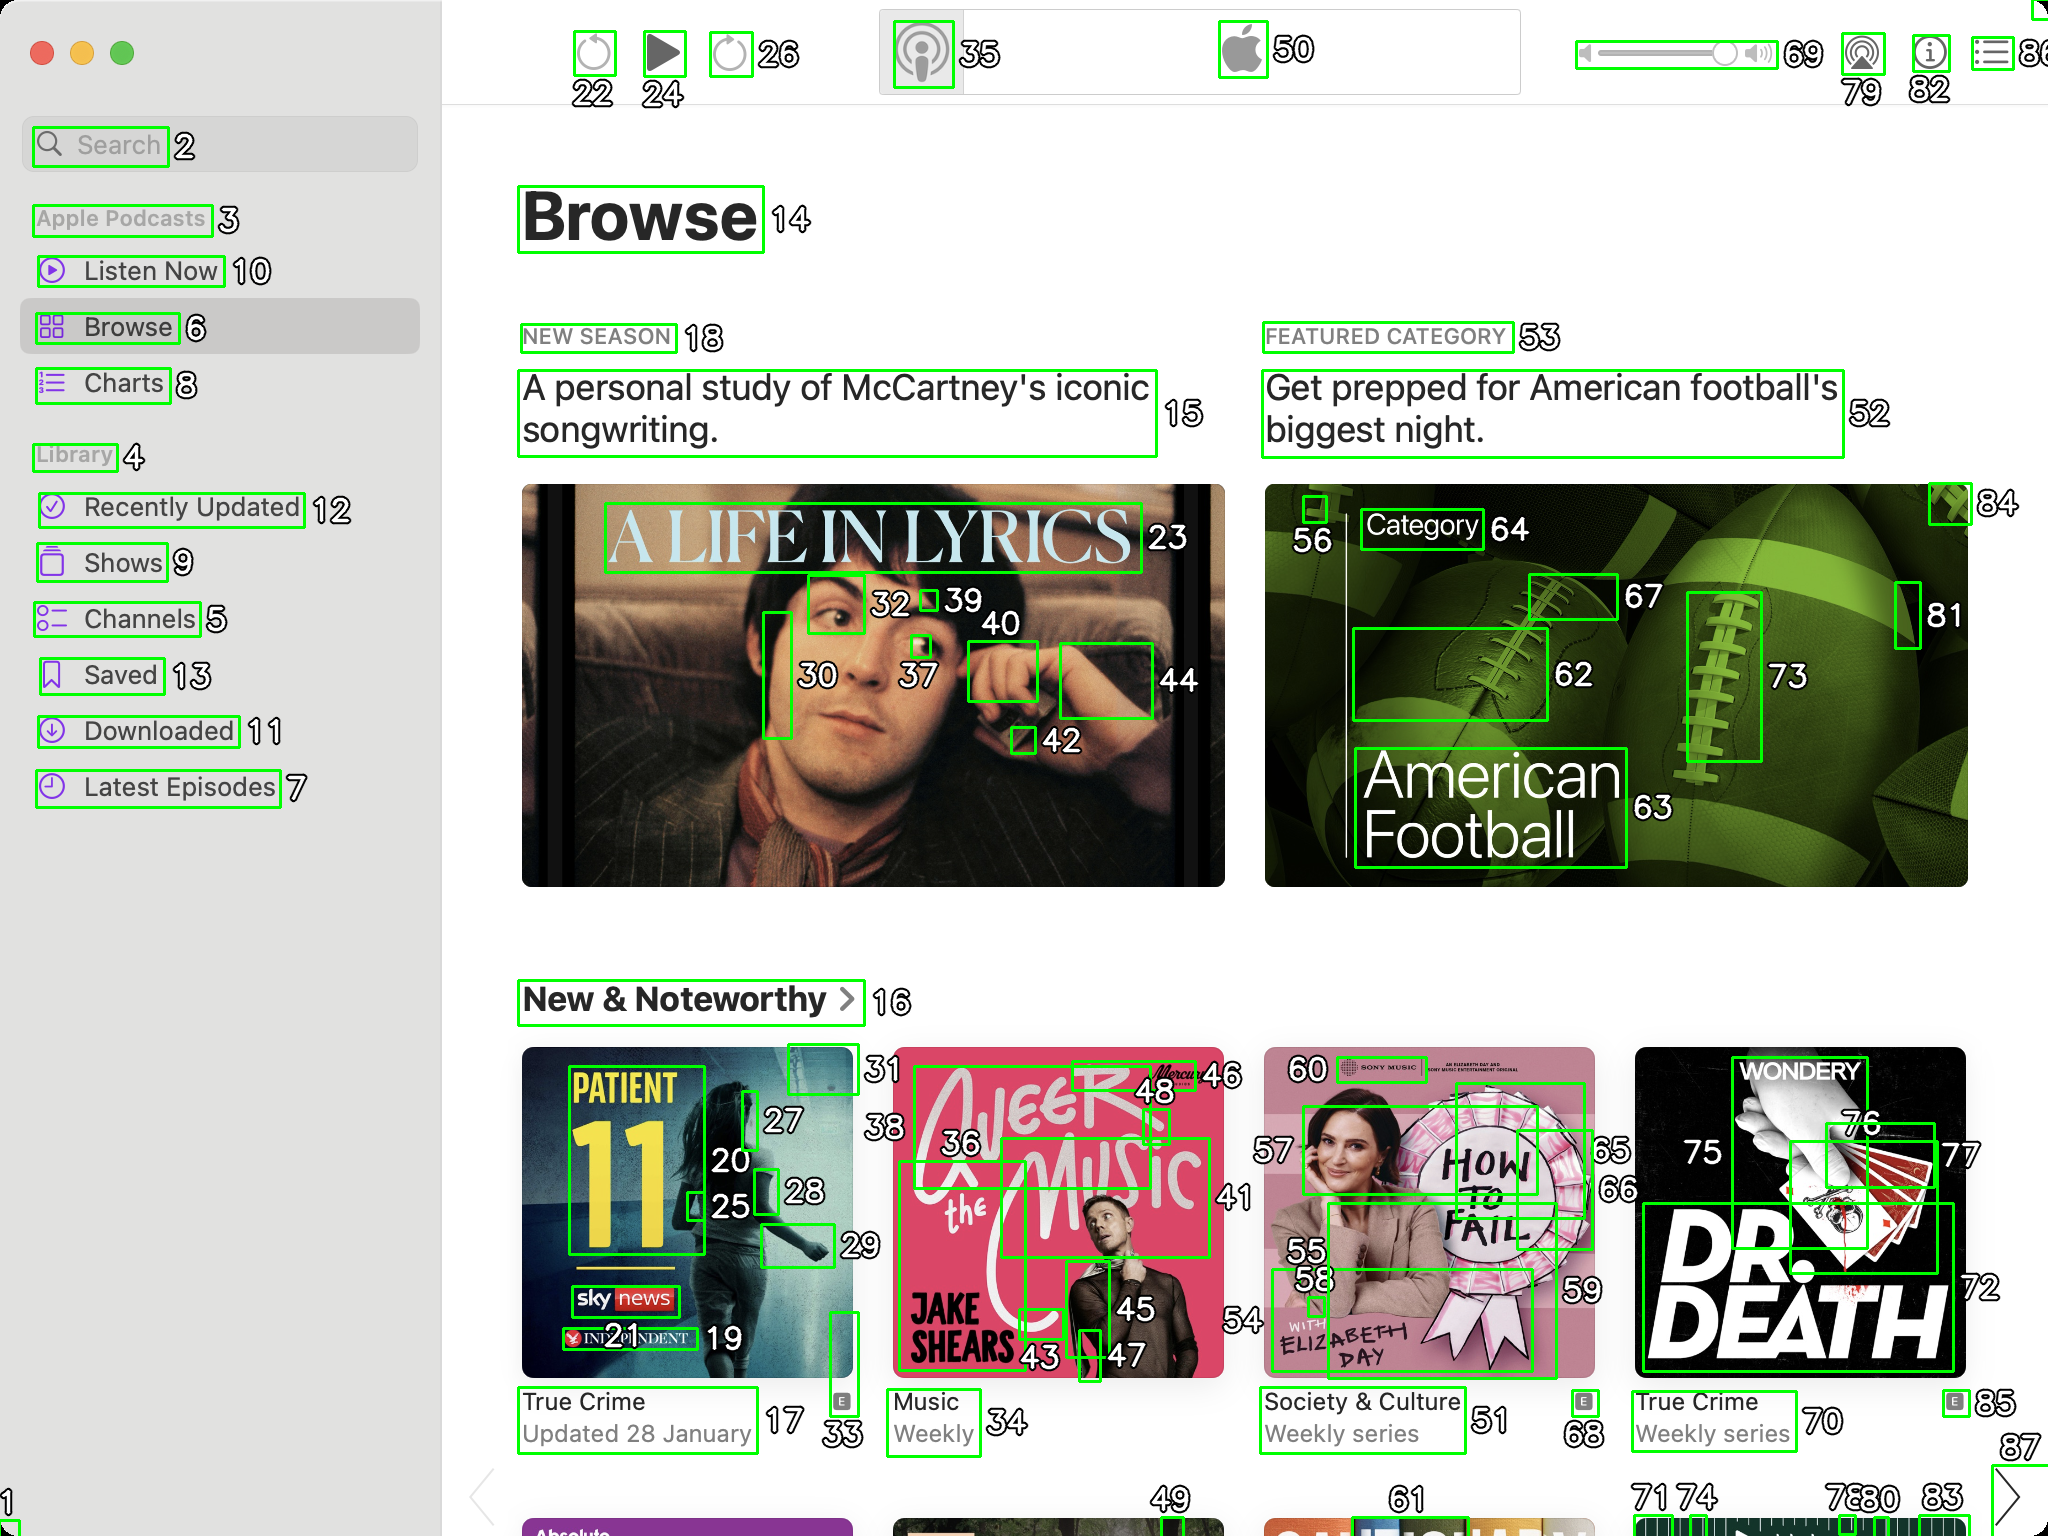You are an AI designed for image processing and segmentation analysis, particularly skilled in merging segmented regions of an image to improve accuracy and readability.

**Task Description:**
Your task is to address a user's concern with a UI screenshot of the Apple Podcasts application on MacOS. The screenshot contains multiple green boxes, each representing a UI element, with a unique white number outlined in black ranging from 1 to 88. Due to segmentation issues, some boxes that belong to the same image are divided unnaturally.

**Objective:**
Merge these segmented areas that correspond to a single UI element to create a coherent representation. The final output should be in JSON format, where each key-value pair represents the merged areas.

**Example JSON Output:**
If boxes with numbers 1, 2, and 3 should belong to the same UI element, the JSON output should be:

```json
{
    "Image A Life In Lyrics": [1, 2, 3]
}
```

**Instructions:**

- **Identify Segmented Regions:** Analyze the screenshot to identify which green boxes belong to the same UI element.
- **Merge Regions:** Group the numbers of these boxes together to represent a single UI element.
- **Output Format:** Produce the output in JSON format, with each key representing a UI element and each value being a list of the numbers of the merged boxes. Don't include in the result UI elements that consist of one box.

**Primary Objective:**
Ensure the accuracy of the merged regions based on the user's supplied image information, maintaining the integrity and structure of the UI elements in the Apple Podcasts application on MacOS. Based on the provided screenshot, I have identified the segmented regions that belong to the same UI elements and merged them accordingly. Here is the JSON output representing the merged areas:

```json
{
    "Search": [2],
    "Apple Podcasts": [3],
    "Listen Now": [10],
    "Browse": [6],
    "Charts": [8],
    "Library": [4],
    "Recently Updated": [12],
    "Shows": [9],
    "Channels": [5],
    "Saved": [13],
    "Downloaded": [11],
    "Latest Episodes": [7],
    "Browse Header": [14],
    "A Life In Lyrics": [15, 23, 30, 32, 37, 39, 40, 42, 44],
    "New Season": [18],
    "Featured Category": [53],
    "Get prepped for American football's biggest night.": [52],
    "American Football": [56, 62, 63, 64, 67, 73, 81, 84],
    "New & Noteworthy": [16],
    "Patient 11": [17, 20, 25, 27, 28, 33],
    "True Crime": [19],
    "Updated 28 January": [21],
    "A Life In Lyrics Category": [24, 26],
    "Jake Shears": [36, 43, 45, 46, 48],
    "Weekly": [35],
    "Music": [34],
    "How To Fail": [55, 58, 59, 60],
    "Society & Culture": [51],
    "Weekly series": [50],
    "Dr. Death": [70, 72, 75, 76, 77],
    "True Crime Weekly series": [68],
    "Updated 28 January": [71],
    "Wondery": [78, 79, 80, 82, 85]
}
```

This JSON output groups the segmented boxes into their respective UI elements, ensuring a coherent representation of the Apple Podcasts application interface. 